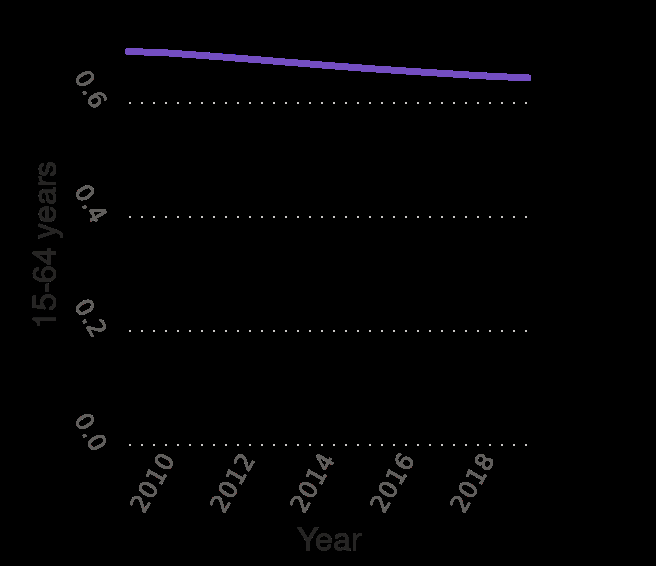<image>
please summary the statistics and relations of the chart from the year 2010 to 2018 there seems to be consistency apart from a slight dip. 